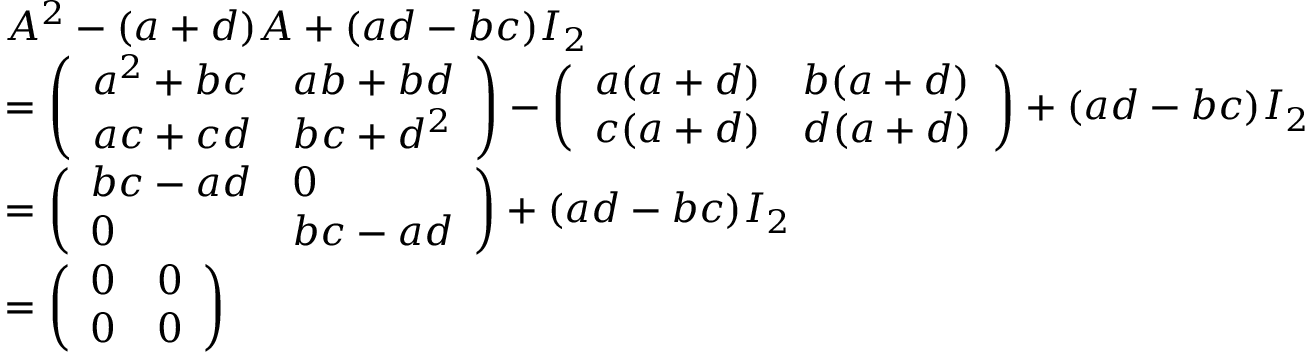<formula> <loc_0><loc_0><loc_500><loc_500>{ \begin{array} { r l } & { A ^ { 2 } - ( a + d ) A + ( a d - b c ) I _ { 2 } } \\ & { = { \left ( \begin{array} { l l } { a ^ { 2 } + b c } & { a b + b d } \\ { a c + c d } & { b c + d ^ { 2 } } \end{array} \right ) } - { \left ( \begin{array} { l l } { a ( a + d ) } & { b ( a + d ) } \\ { c ( a + d ) } & { d ( a + d ) } \end{array} \right ) } + ( a d - b c ) I _ { 2 } } \\ & { = { \left ( \begin{array} { l l } { b c - a d } & { 0 } \\ { 0 } & { b c - a d } \end{array} \right ) } + ( a d - b c ) I _ { 2 } } \\ & { = { \left ( \begin{array} { l l } { 0 } & { 0 } \\ { 0 } & { 0 } \end{array} \right ) } } \end{array} }</formula> 